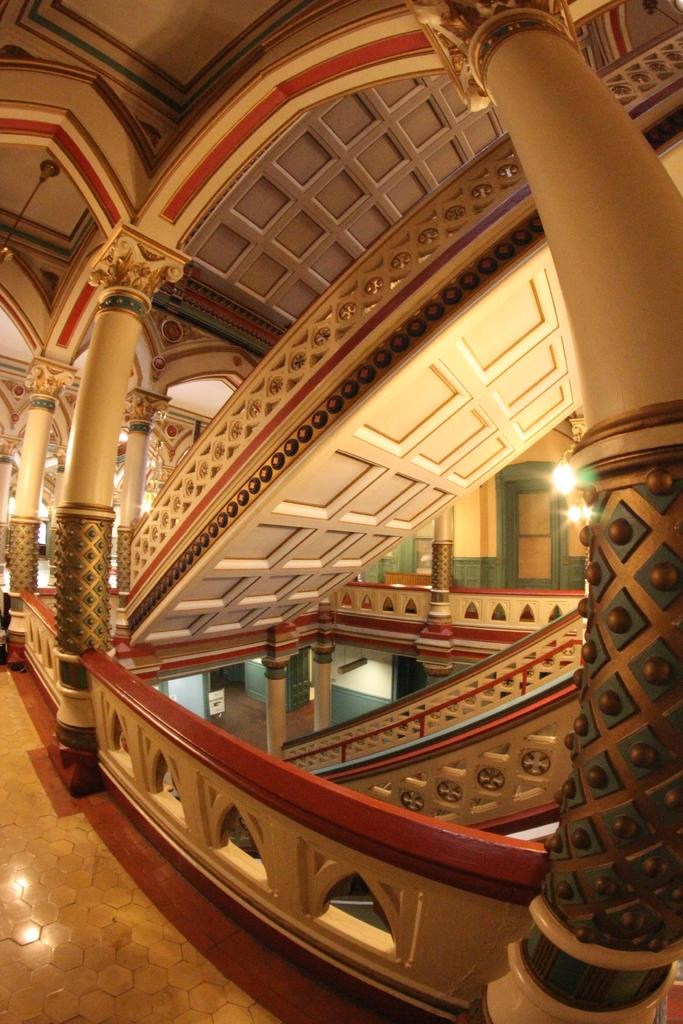What type of location is depicted in the image? The image shows an inside view of a building. Can you describe any specific features of the building's interior? There are lights visible in the image. What type of health advice can be seen on the map in the image? There is no map present in the image, and therefore no health advice can be seen. 